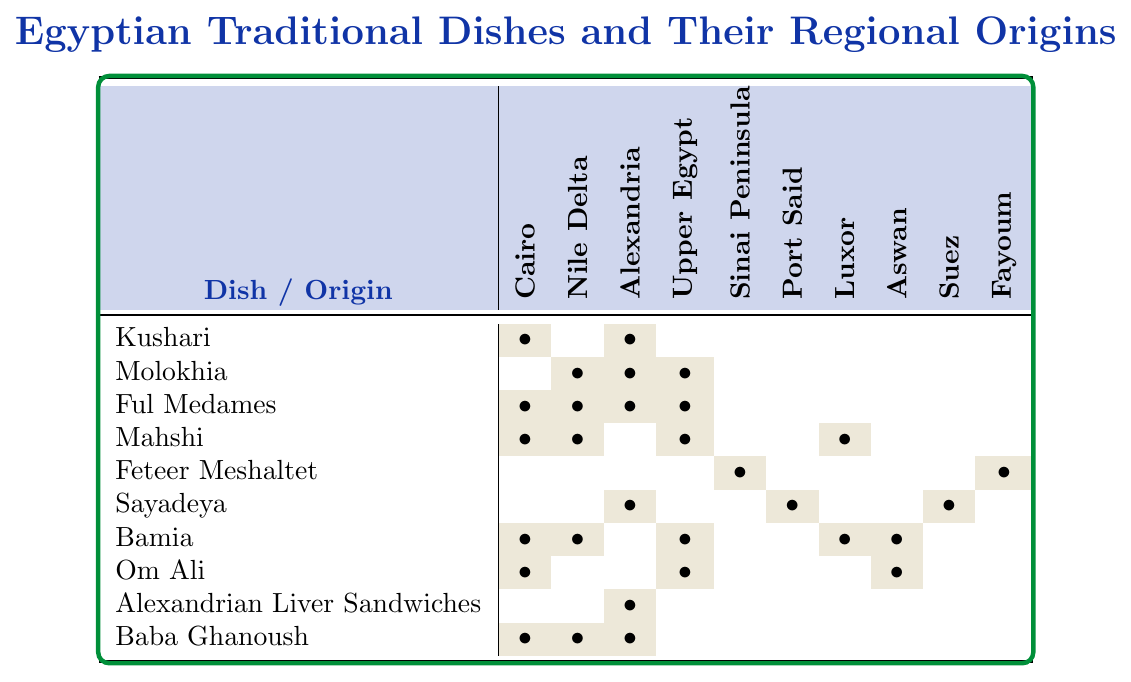What region is Kushari most associated with? According to the table, Kushari has marks in the Cairo and Alexandria columns, which indicates that it is traditionally associated with both regions.
Answer: Cairo and Alexandria Does Ful Medames originate from Upper Egypt? The table shows that Ful Medames has a mark in the Upper Egypt column. This means it does not originate from there, as it also has other associations in different regions.
Answer: Yes How many dishes are associated with Alexandria? By looking at the Alexandria column, there are five dishes marked: Molokhia, Sayadeya, Alexandrian Liver Sandwiches, Baba Ghanoush, and Ful Medames.
Answer: 5 Out of the dishes listed, which one is specifically tied to the Sinai Peninsula? The table shows that Feteer Meshaltet is the only dish marked in the Sinai Peninsula column.
Answer: Feteer Meshaltet Are there any dishes uniquely associated with Cairo? By analyzing the Cairo column, Kushari is marked but also appears in Alexandria, indicating it is not unique to Cairo. Thus, there are no uniquely associated dishes.
Answer: No Which region has the highest number of dishes associated with it? By counting the marked dishes, Nile Delta and Cairo each have four, while Alexandria has five. Therefore, Alexandria holds the highest number of dishes, even though others like Cairo have many as well.
Answer: Alexandria Is there a dish that is common in both Luxor and Bamia regions? The table indicates that the Bamia dish is marked in both Luxor and the Bamia column. This confirms that Bamia is associated with both regions.
Answer: Yes How many dishes come from the Upper Egypt region and are also marked for the Nile Delta? Checking the dishes, the ones marked for both Upper Egypt and Nile Delta are Mahshi and Bamia. Therefore, two dishes are distinctly marked in those categories.
Answer: 2 What percentage of the dishes on the table are associated with Port Said? The only dish marked in the Port Said column is Sayadeya. Since there are ten total dishes, the percentage is (1/10) * 100 = 10%.
Answer: 10% Which dish is associated with the most diverse regions, based on this table? Ful Medames appears in Cairo, Nile Delta, Alexandria, and Upper Egypt. So it shows the most diversity, being marked in four regions.
Answer: Ful Medames 